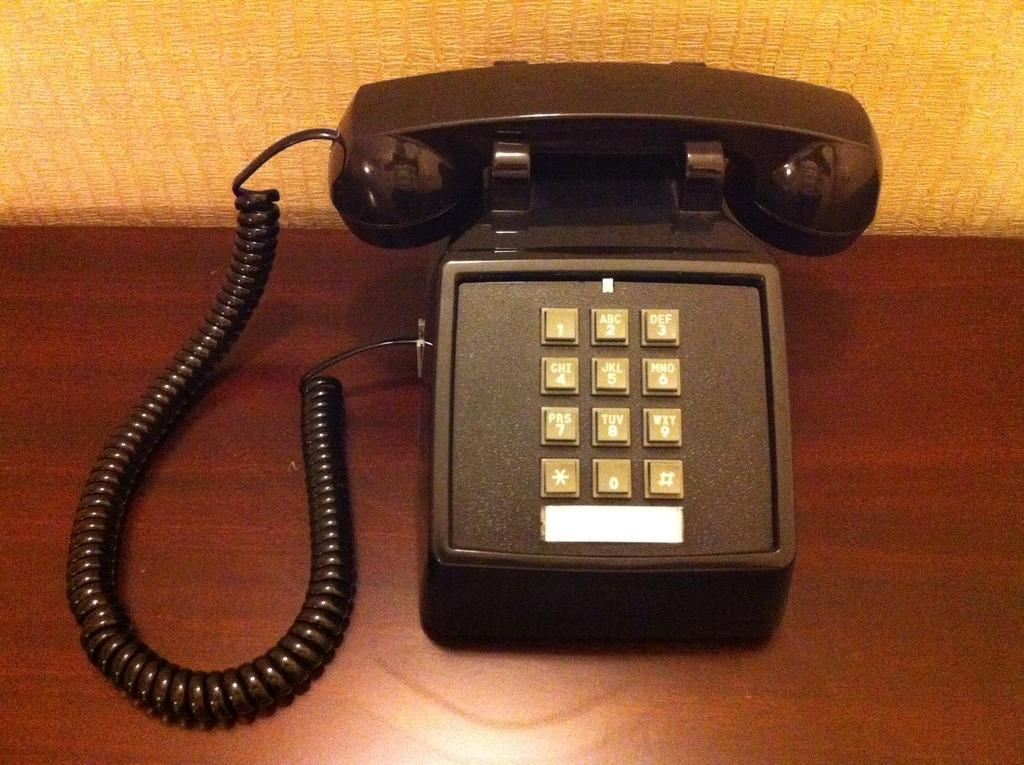What object is the main subject of the image? There is a telephone in the image. What is the color of the surface on which the telephone is placed? The telephone is on a brown surface. What color is the background of the image? The background of the image is yellow. How does the needle move in the image? There is no needle present in the image. 